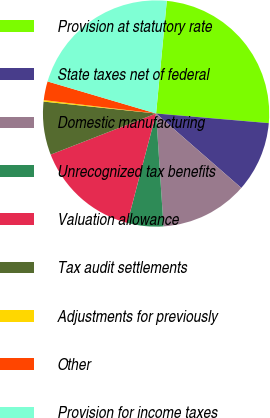<chart> <loc_0><loc_0><loc_500><loc_500><pie_chart><fcel>Provision at statutory rate<fcel>State taxes net of federal<fcel>Domestic manufacturing<fcel>Unrecognized tax benefits<fcel>Valuation allowance<fcel>Tax audit settlements<fcel>Adjustments for previously<fcel>Other<fcel>Provision for income taxes<nl><fcel>24.85%<fcel>10.07%<fcel>12.53%<fcel>5.14%<fcel>14.99%<fcel>7.6%<fcel>0.21%<fcel>2.68%<fcel>21.94%<nl></chart> 